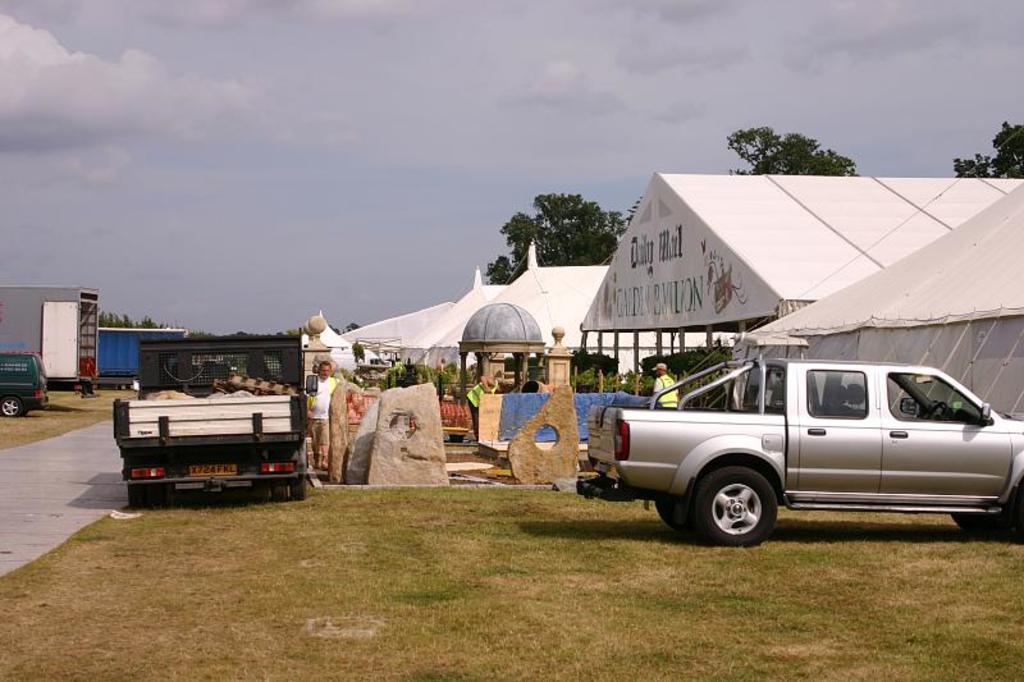In one or two sentences, can you explain what this image depicts? In this picture I can see few tents and few people are standing and I can see a truck and a mini truck and I can see a car and few metal containers and I can see trees, plants and a cloudy sky and I can see grass on the ground. 